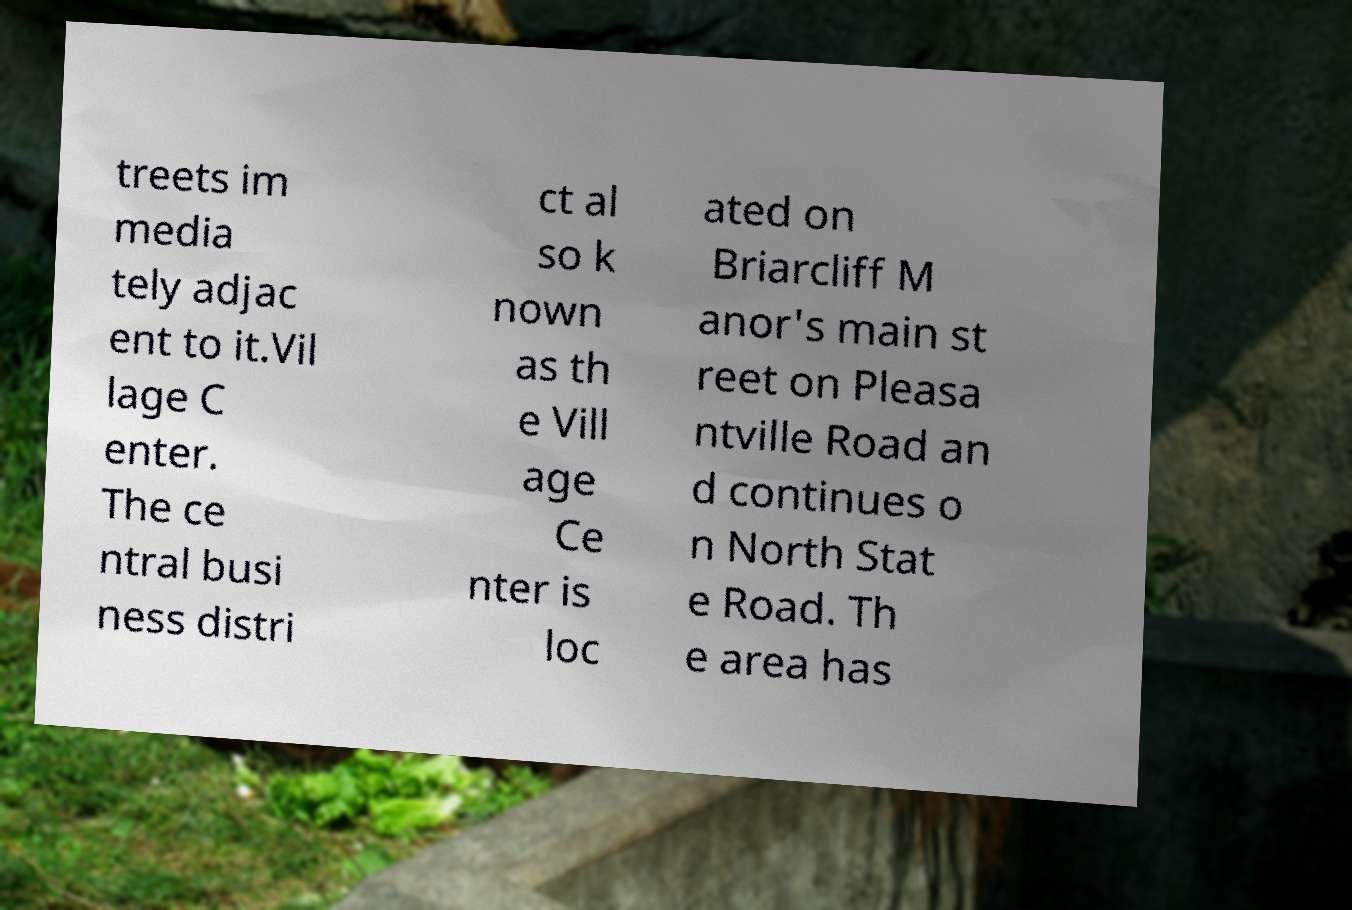What messages or text are displayed in this image? I need them in a readable, typed format. treets im media tely adjac ent to it.Vil lage C enter. The ce ntral busi ness distri ct al so k nown as th e Vill age Ce nter is loc ated on Briarcliff M anor's main st reet on Pleasa ntville Road an d continues o n North Stat e Road. Th e area has 